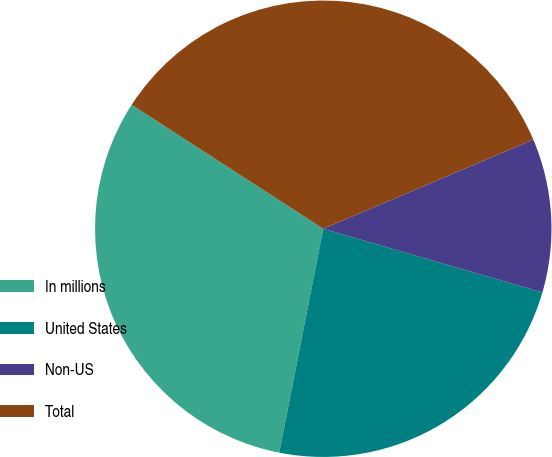Convert chart to OTSL. <chart><loc_0><loc_0><loc_500><loc_500><pie_chart><fcel>In millions<fcel>United States<fcel>Non-US<fcel>Total<nl><fcel>31.05%<fcel>23.59%<fcel>10.89%<fcel>34.47%<nl></chart> 